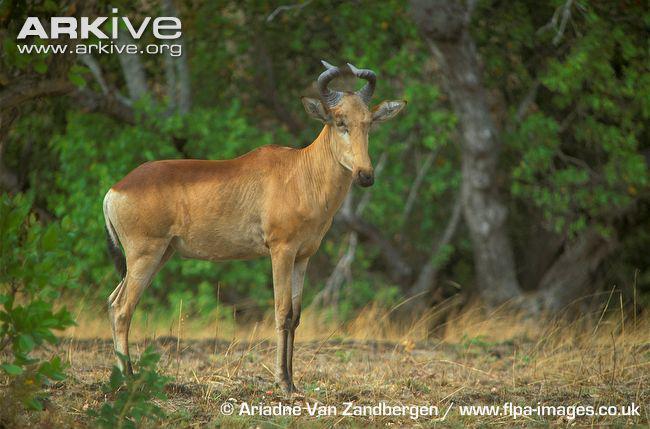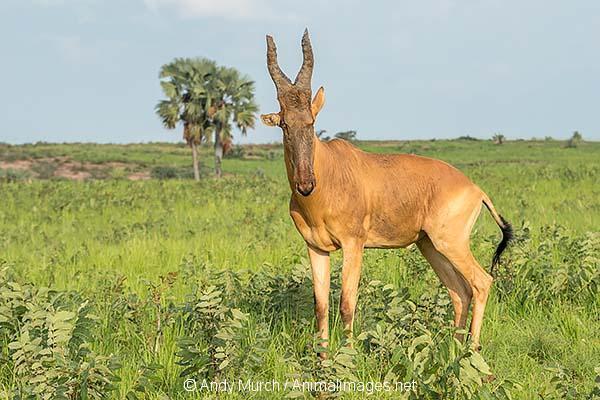The first image is the image on the left, the second image is the image on the right. For the images shown, is this caption "There are exactly three goats." true? Answer yes or no. No. The first image is the image on the left, the second image is the image on the right. Given the left and right images, does the statement "One image contains two upright horned animals engaged in physical contact, and the other image contains one horned animal standing in profile." hold true? Answer yes or no. No. 